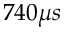Convert formula to latex. <formula><loc_0><loc_0><loc_500><loc_500>7 4 0 \mu s</formula> 